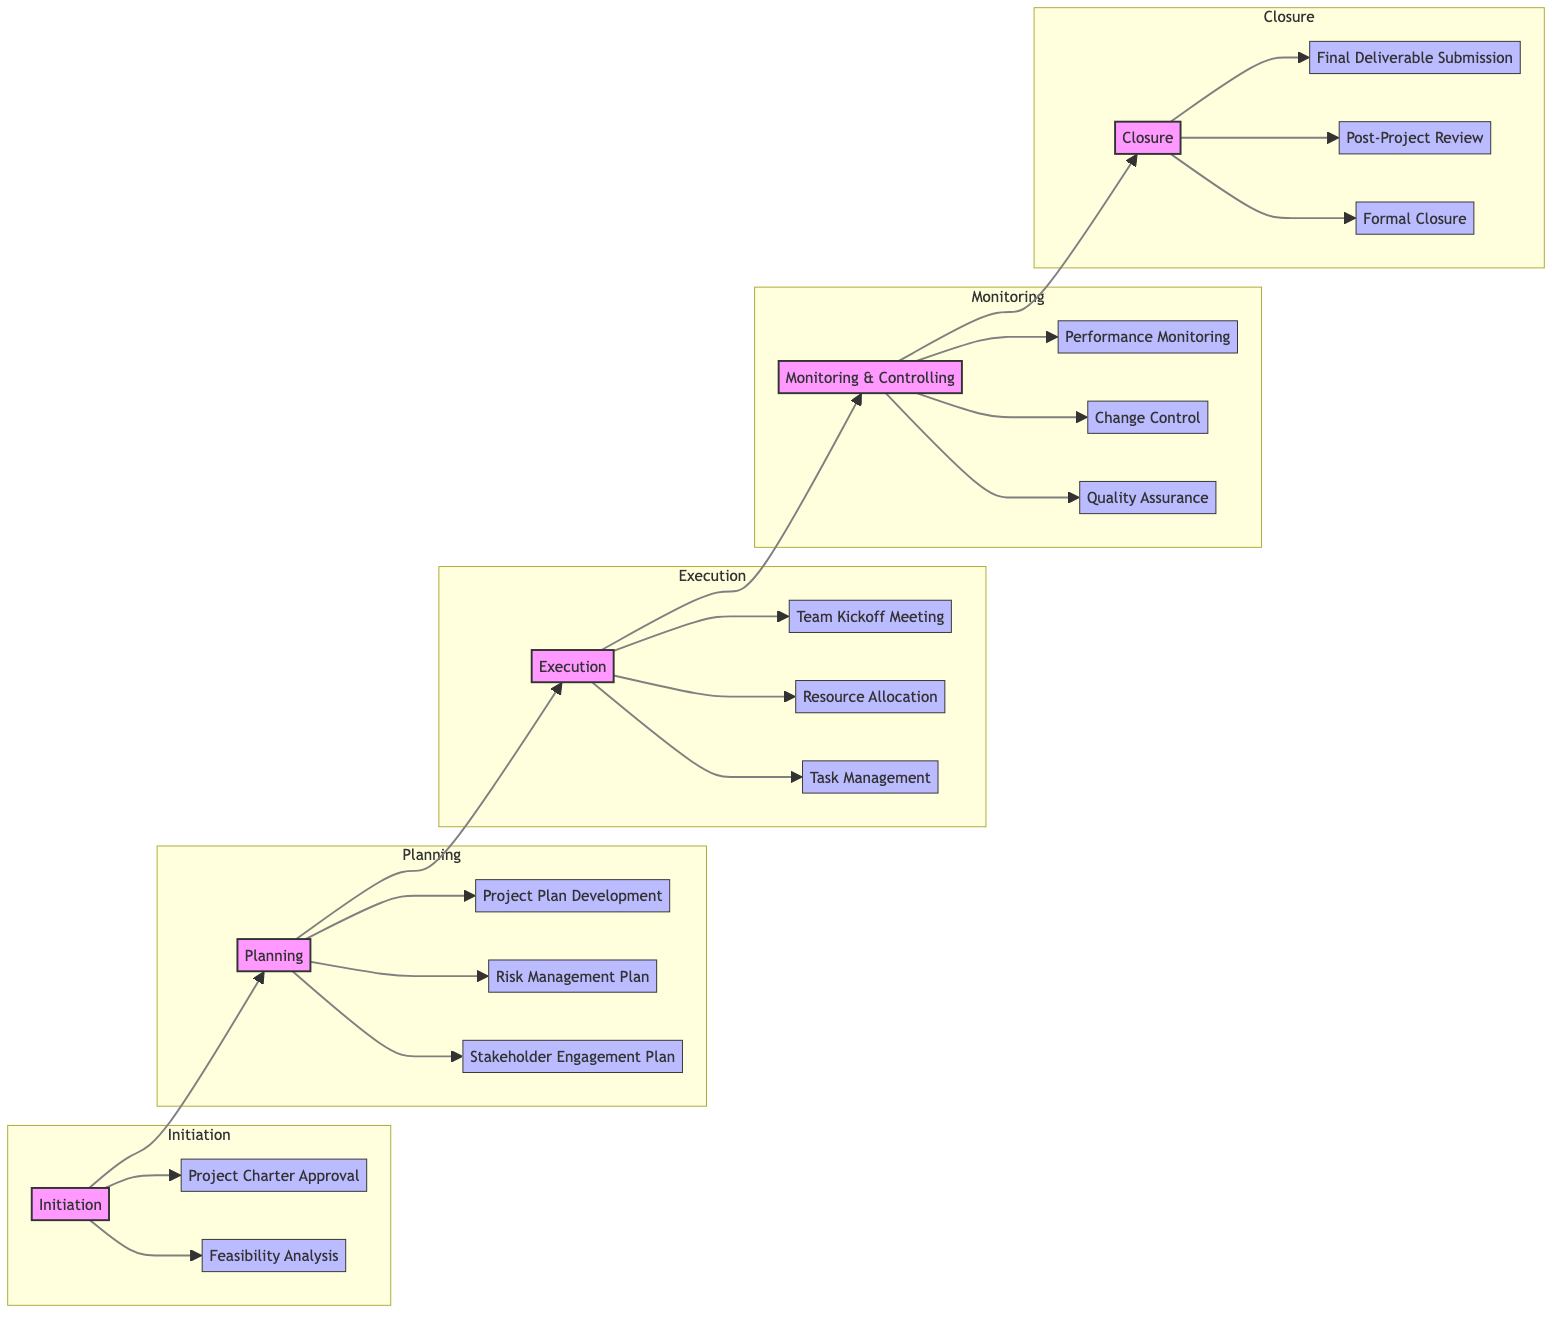What's the first phase in the workflow? The diagram begins with the "Initiation" phase as the starting point in the project management workflow.
Answer: Initiation How many milestones are in the Planning phase? The Planning phase has three milestones listed: Project Plan Development, Risk Management Plan, and Stakeholder Engagement Plan. Therefore, there are a total of three milestones.
Answer: 3 What is the last milestone in the Closure phase? The last milestone listed in the Closure phase is "Formal Closure," which is the final step in this phase.
Answer: Formal Closure Which phase comes immediately after the Execution phase? The diagram shows a direct flow from Execution to the Monitoring & Controlling phase, indicating that Monitoring & Controlling follows Execution.
Answer: Monitoring & Controlling What is the relationship between "Team Kickoff Meeting" and "Risk Management Plan"? The "Team Kickoff Meeting" is part of the Execution phase, while the "Risk Management Plan" is a milestone in the Planning phase. These two milestones are in different phases and are not directly related but part of the sequential workflow.
Answer: Different phases How many total phases are represented in the diagram? The project management workflow comprises five distinct phases: Initiation, Planning, Execution, Monitoring & Controlling, and Closure, which adds up to a total of five phases.
Answer: 5 What milestone is focused on the quality of deliverables? The milestone dedicated to ensuring the quality of deliverables is "Quality Assurance," which is listed under the Monitoring & Controlling phase.
Answer: Quality Assurance Which phase precedes the Monitoring & Controlling phase? The phase that comes just before Monitoring & Controlling in the flowchart is Execution, indicating that project execution must occur before monitoring and controlling can take place.
Answer: Execution Name a milestone that deals with stakeholder interaction. "Stakeholder Engagement Plan" in the Planning phase is specifically focused on strategies to engage and communicate with stakeholders.
Answer: Stakeholder Engagement Plan 